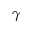<formula> <loc_0><loc_0><loc_500><loc_500>\gamma</formula> 